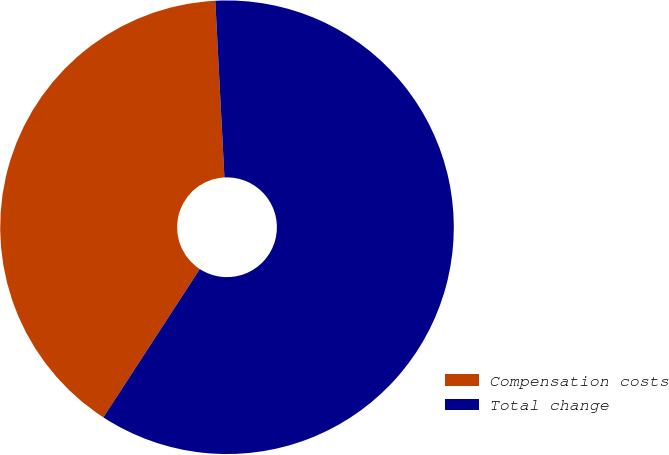<chart> <loc_0><loc_0><loc_500><loc_500><pie_chart><fcel>Compensation costs<fcel>Total change<nl><fcel>40.0%<fcel>60.0%<nl></chart> 